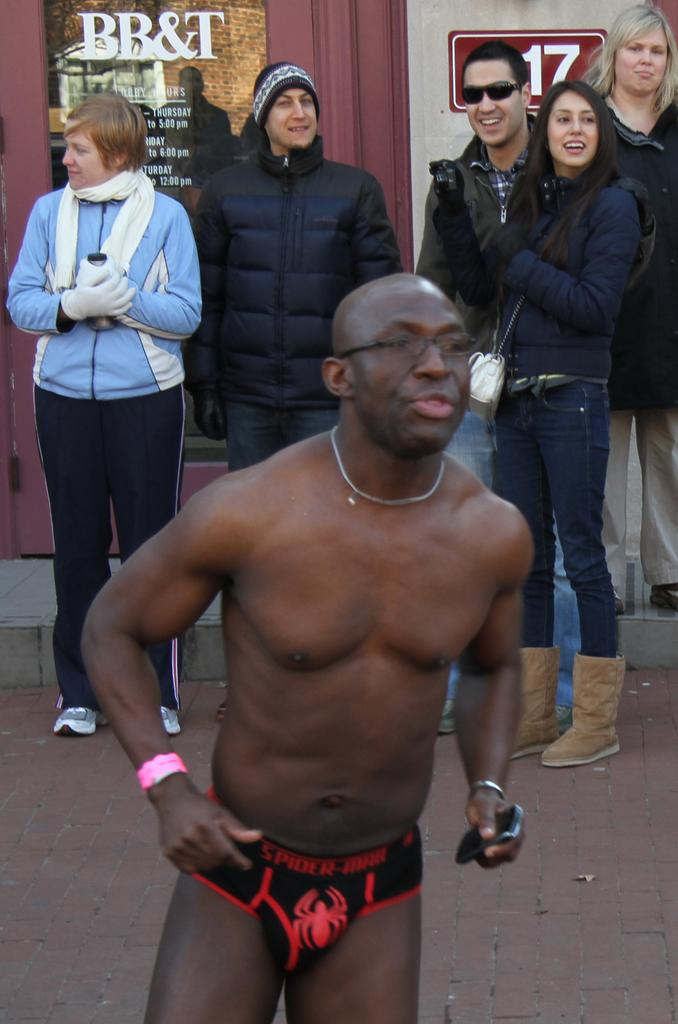What is the main subject of the image? The main subject of the image is a group of people. Where are the people located in the image? The people are standing on the road. What type of pickle is being used as a prop in the image? There is no pickle present in the image. What word is being spelled out by the people in the image? There is no indication in the image that the people are spelling out a word. 